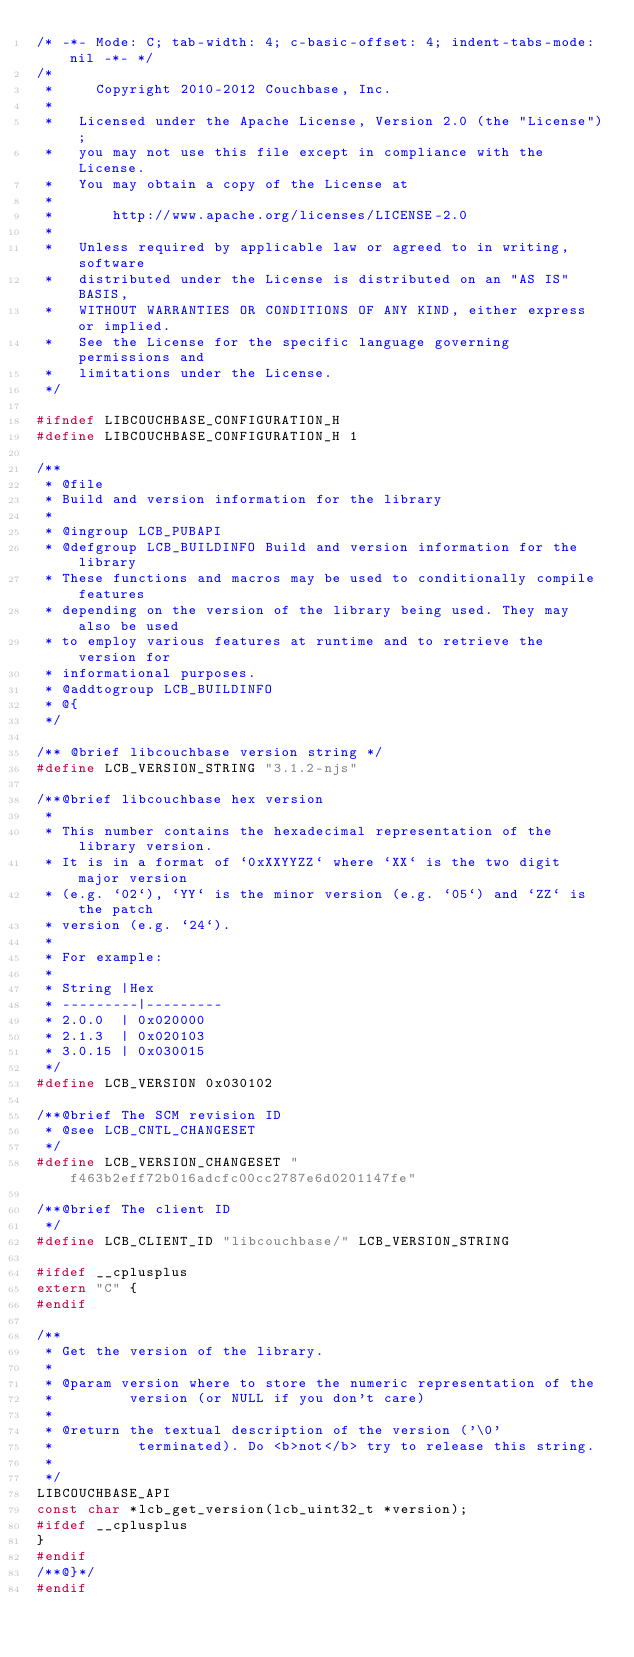<code> <loc_0><loc_0><loc_500><loc_500><_C_>/* -*- Mode: C; tab-width: 4; c-basic-offset: 4; indent-tabs-mode: nil -*- */
/*
 *     Copyright 2010-2012 Couchbase, Inc.
 *
 *   Licensed under the Apache License, Version 2.0 (the "License");
 *   you may not use this file except in compliance with the License.
 *   You may obtain a copy of the License at
 *
 *       http://www.apache.org/licenses/LICENSE-2.0
 *
 *   Unless required by applicable law or agreed to in writing, software
 *   distributed under the License is distributed on an "AS IS" BASIS,
 *   WITHOUT WARRANTIES OR CONDITIONS OF ANY KIND, either express or implied.
 *   See the License for the specific language governing permissions and
 *   limitations under the License.
 */

#ifndef LIBCOUCHBASE_CONFIGURATION_H
#define LIBCOUCHBASE_CONFIGURATION_H 1

/**
 * @file
 * Build and version information for the library
 *
 * @ingroup LCB_PUBAPI
 * @defgroup LCB_BUILDINFO Build and version information for the library
 * These functions and macros may be used to conditionally compile features
 * depending on the version of the library being used. They may also be used
 * to employ various features at runtime and to retrieve the version for
 * informational purposes.
 * @addtogroup LCB_BUILDINFO
 * @{
 */

/** @brief libcouchbase version string */
#define LCB_VERSION_STRING "3.1.2-njs"

/**@brief libcouchbase hex version
 *
 * This number contains the hexadecimal representation of the library version.
 * It is in a format of `0xXXYYZZ` where `XX` is the two digit major version
 * (e.g. `02`), `YY` is the minor version (e.g. `05`) and `ZZ` is the patch
 * version (e.g. `24`).
 *
 * For example:
 *
 * String	|Hex
 * ---------|---------
 * 2.0.0	| 0x020000
 * 2.1.3	| 0x020103
 * 3.0.15	| 0x030015
 */
#define LCB_VERSION 0x030102

/**@brief The SCM revision ID
 * @see LCB_CNTL_CHANGESET
 */
#define LCB_VERSION_CHANGESET "f463b2eff72b016adcfc00cc2787e6d0201147fe"

/**@brief The client ID
 */
#define LCB_CLIENT_ID "libcouchbase/" LCB_VERSION_STRING

#ifdef __cplusplus
extern "C" {
#endif

/**
 * Get the version of the library.
 *
 * @param version where to store the numeric representation of the
 *         version (or NULL if you don't care)
 *
 * @return the textual description of the version ('\0'
 *          terminated). Do <b>not</b> try to release this string.
 *
 */
LIBCOUCHBASE_API
const char *lcb_get_version(lcb_uint32_t *version);
#ifdef __cplusplus
}
#endif
/**@}*/
#endif
</code> 